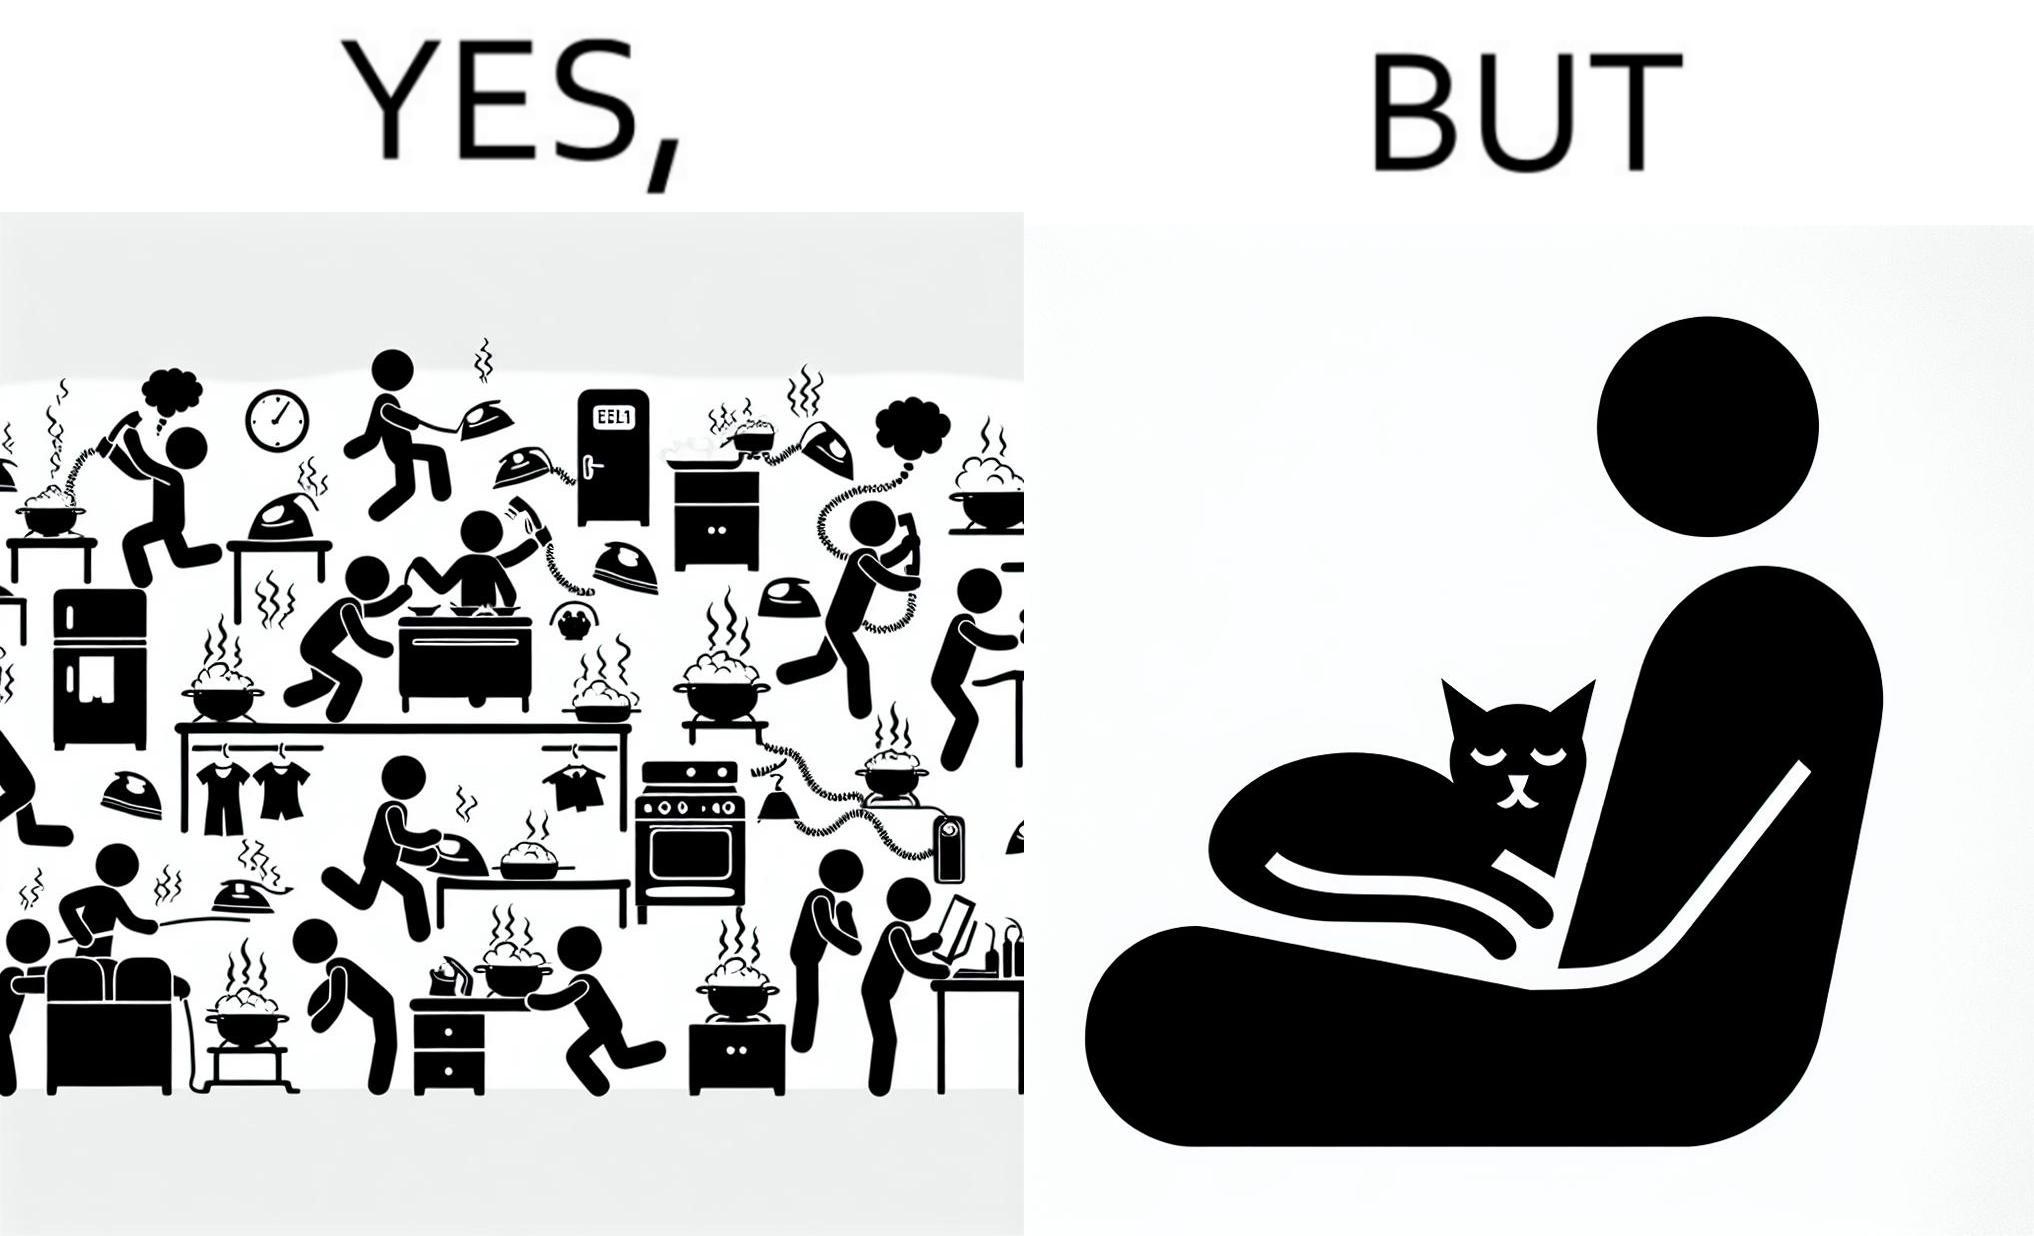Describe the satirical element in this image. the irony in this image is that people ignore all the chaos around them and get distracted by a cat. 